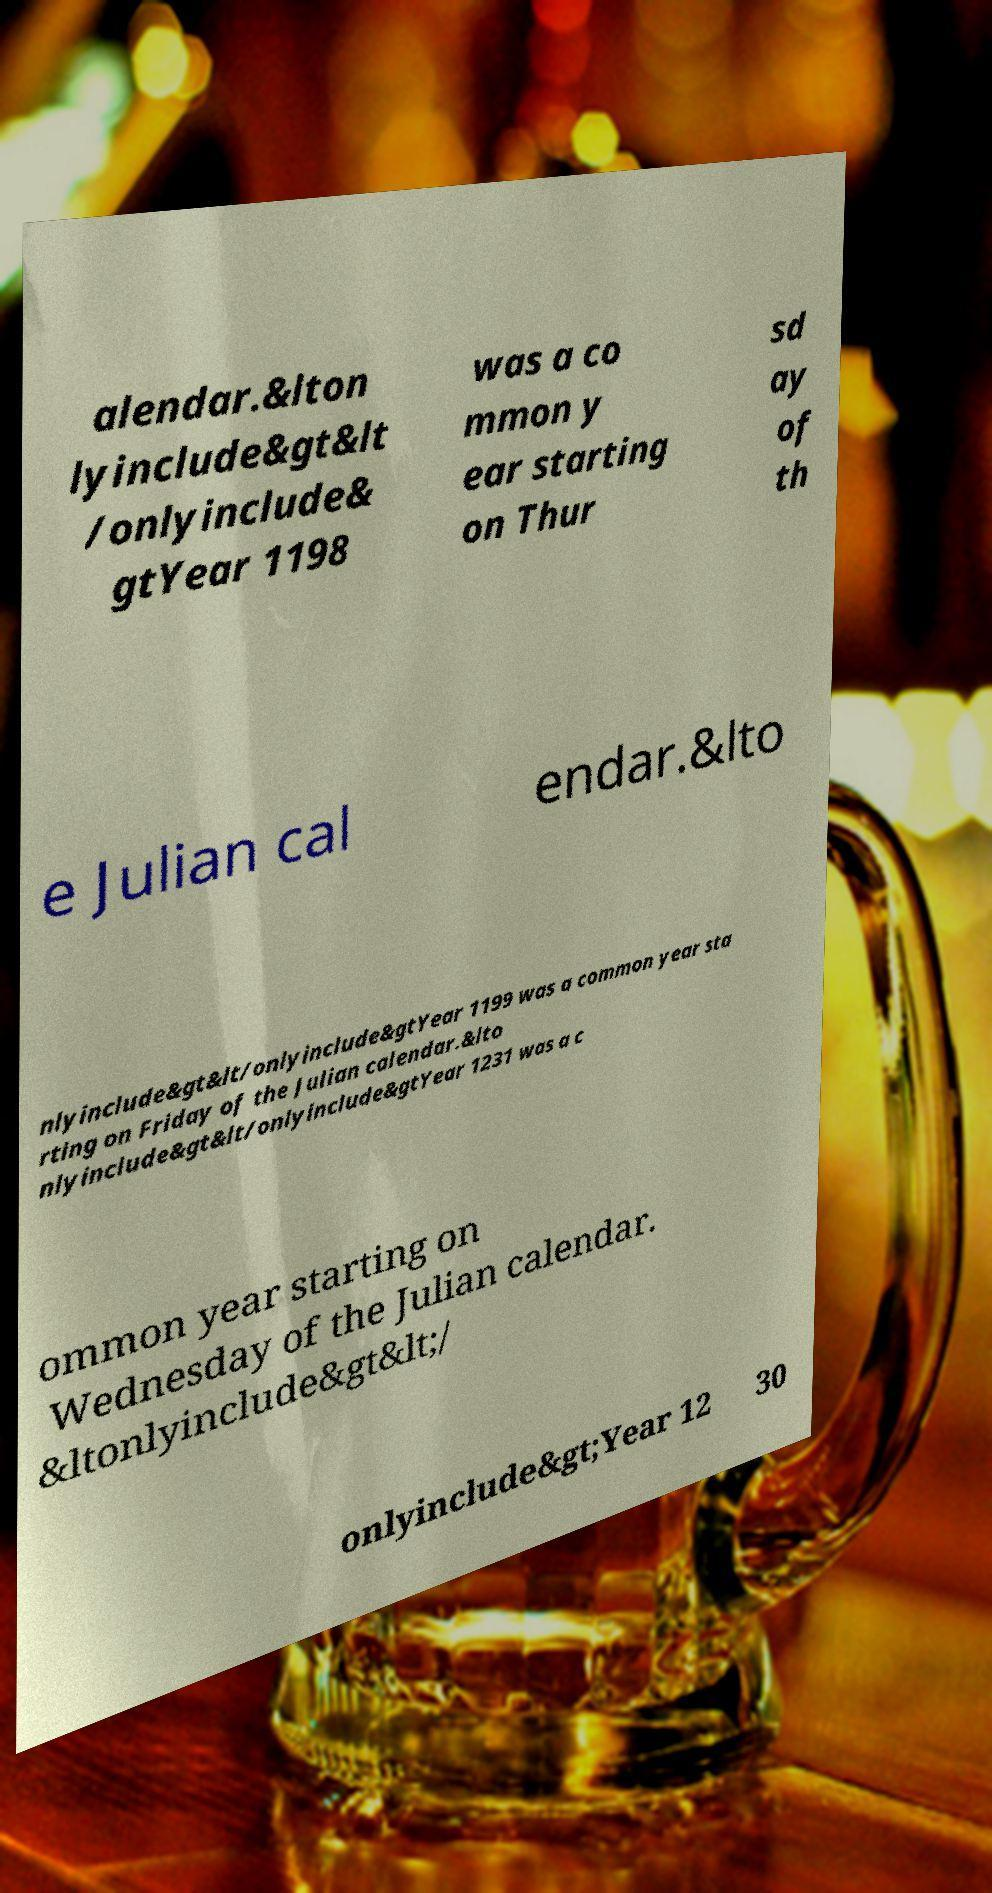Please read and relay the text visible in this image. What does it say? alendar.&lton lyinclude&gt&lt /onlyinclude& gtYear 1198 was a co mmon y ear starting on Thur sd ay of th e Julian cal endar.&lto nlyinclude&gt&lt/onlyinclude&gtYear 1199 was a common year sta rting on Friday of the Julian calendar.&lto nlyinclude&gt&lt/onlyinclude&gtYear 1231 was a c ommon year starting on Wednesday of the Julian calendar. &ltonlyinclude&gt&lt;/ onlyinclude&gt;Year 12 30 